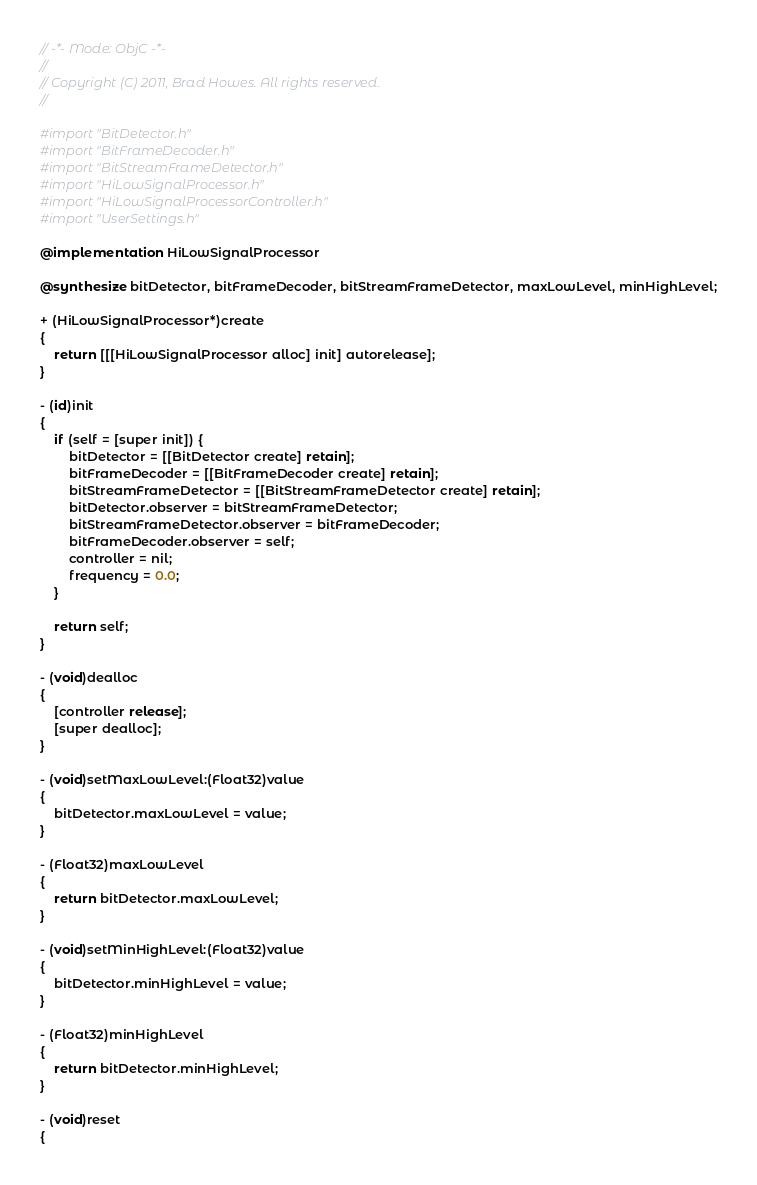<code> <loc_0><loc_0><loc_500><loc_500><_ObjectiveC_>// -*- Mode: ObjC -*-
//
// Copyright (C) 2011, Brad Howes. All rights reserved.
//

#import "BitDetector.h"
#import "BitFrameDecoder.h"
#import "BitStreamFrameDetector.h"
#import "HiLowSignalProcessor.h"
#import "HiLowSignalProcessorController.h"
#import "UserSettings.h"

@implementation HiLowSignalProcessor

@synthesize bitDetector, bitFrameDecoder, bitStreamFrameDetector, maxLowLevel, minHighLevel;

+ (HiLowSignalProcessor*)create
{
    return [[[HiLowSignalProcessor alloc] init] autorelease];
}

- (id)init
{
    if (self = [super init]) {
        bitDetector = [[BitDetector create] retain];
        bitFrameDecoder = [[BitFrameDecoder create] retain];
        bitStreamFrameDetector = [[BitStreamFrameDetector create] retain];
        bitDetector.observer = bitStreamFrameDetector;
        bitStreamFrameDetector.observer = bitFrameDecoder;
        bitFrameDecoder.observer = self;
        controller = nil;
        frequency = 0.0;
    }
    
    return self;
}

- (void)dealloc
{
    [controller release];
    [super dealloc];
}

- (void)setMaxLowLevel:(Float32)value
{
    bitDetector.maxLowLevel = value;
}

- (Float32)maxLowLevel
{
    return bitDetector.maxLowLevel;
}

- (void)setMinHighLevel:(Float32)value
{
    bitDetector.minHighLevel = value;
}

- (Float32)minHighLevel
{
    return bitDetector.minHighLevel;
}

- (void)reset
{</code> 